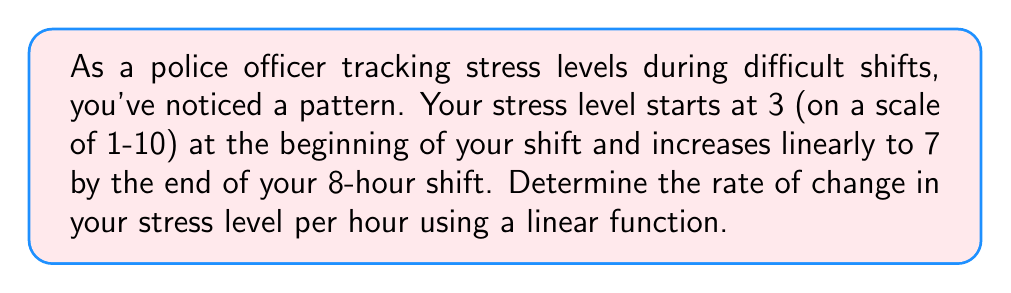Help me with this question. Let's approach this step-by-step:

1) We can represent this situation with a linear function:
   $y = mx + b$
   where $y$ is the stress level, $x$ is the time in hours, $m$ is the rate of change (slope), and $b$ is the initial stress level.

2) We know two points on this line:
   At the start of the shift (0 hours): (0, 3)
   At the end of the shift (8 hours): (8, 7)

3) We can find the slope (rate of change) using the slope formula:
   $m = \frac{y_2 - y_1}{x_2 - x_1} = \frac{7 - 3}{8 - 0} = \frac{4}{8} = 0.5$

4) This means the stress level increases by 0.5 units per hour.

5) We can verify this by writing the complete linear function:
   $y = 0.5x + 3$

6) Checking our end point:
   At 8 hours: $y = 0.5(8) + 3 = 4 + 3 = 7$, which matches our given information.
Answer: 0.5 units per hour 